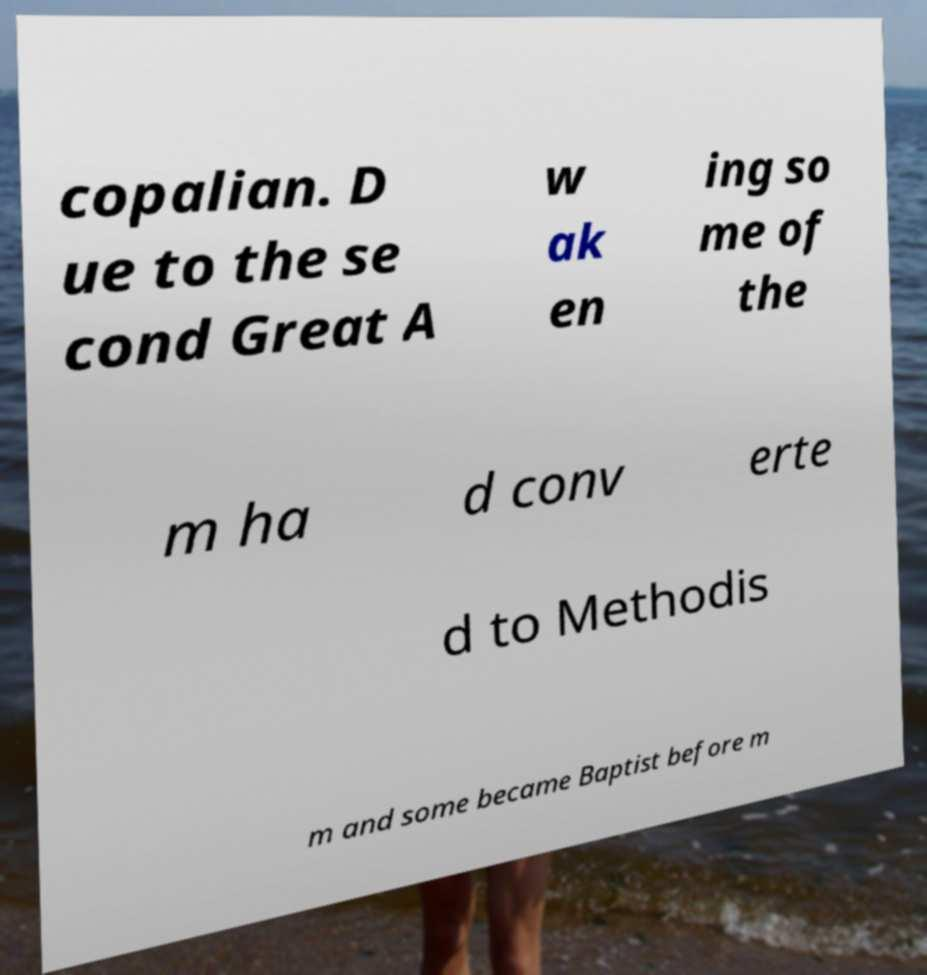Can you accurately transcribe the text from the provided image for me? copalian. D ue to the se cond Great A w ak en ing so me of the m ha d conv erte d to Methodis m and some became Baptist before m 